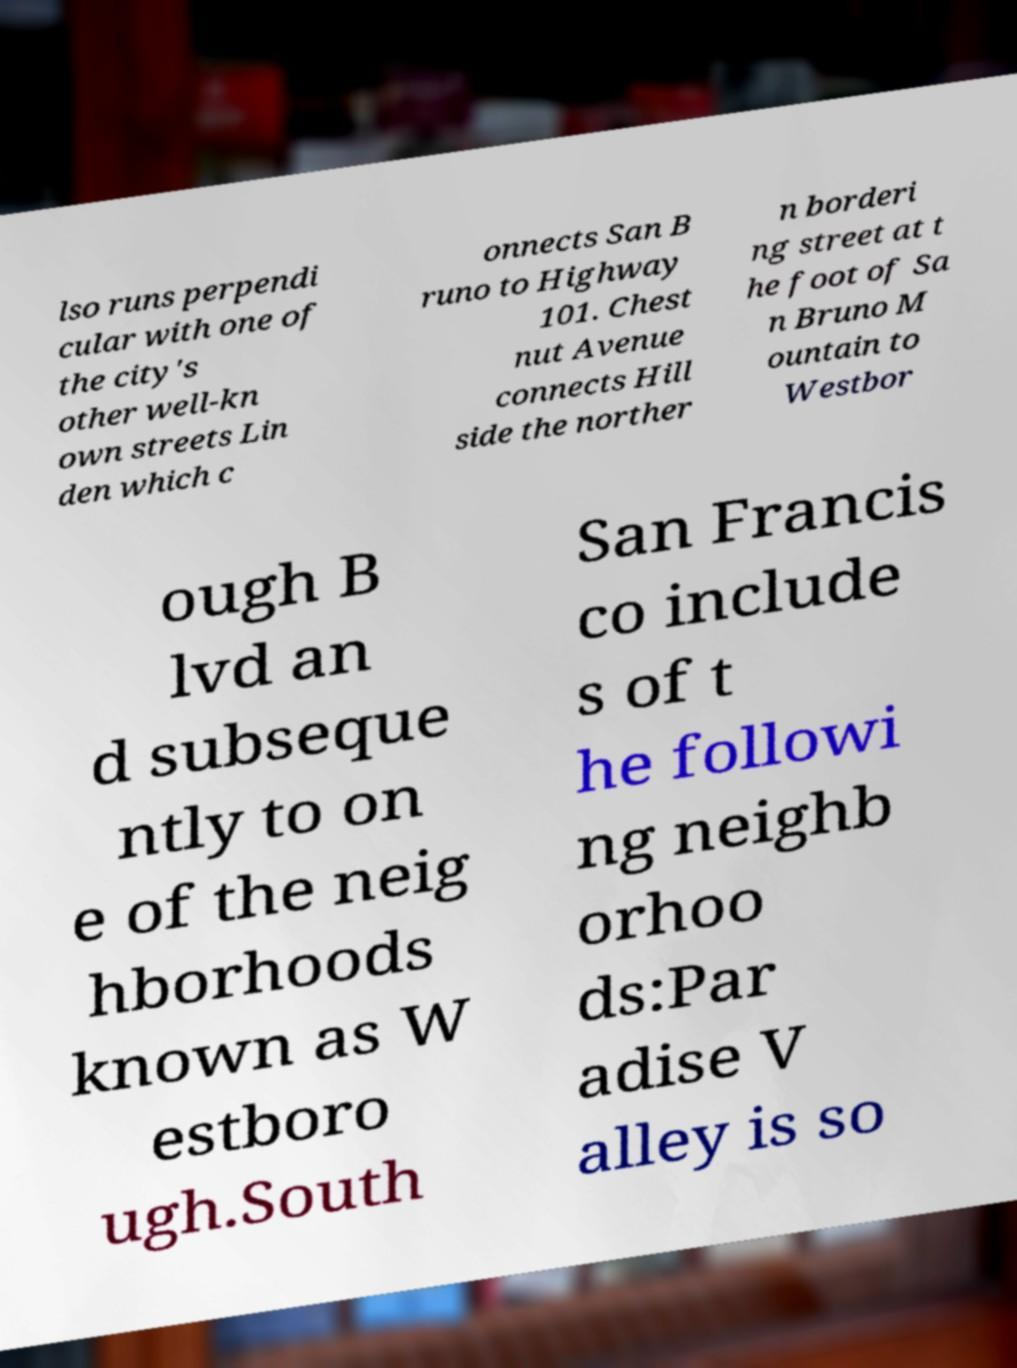Please read and relay the text visible in this image. What does it say? lso runs perpendi cular with one of the city's other well-kn own streets Lin den which c onnects San B runo to Highway 101. Chest nut Avenue connects Hill side the norther n borderi ng street at t he foot of Sa n Bruno M ountain to Westbor ough B lvd an d subseque ntly to on e of the neig hborhoods known as W estboro ugh.South San Francis co include s of t he followi ng neighb orhoo ds:Par adise V alley is so 